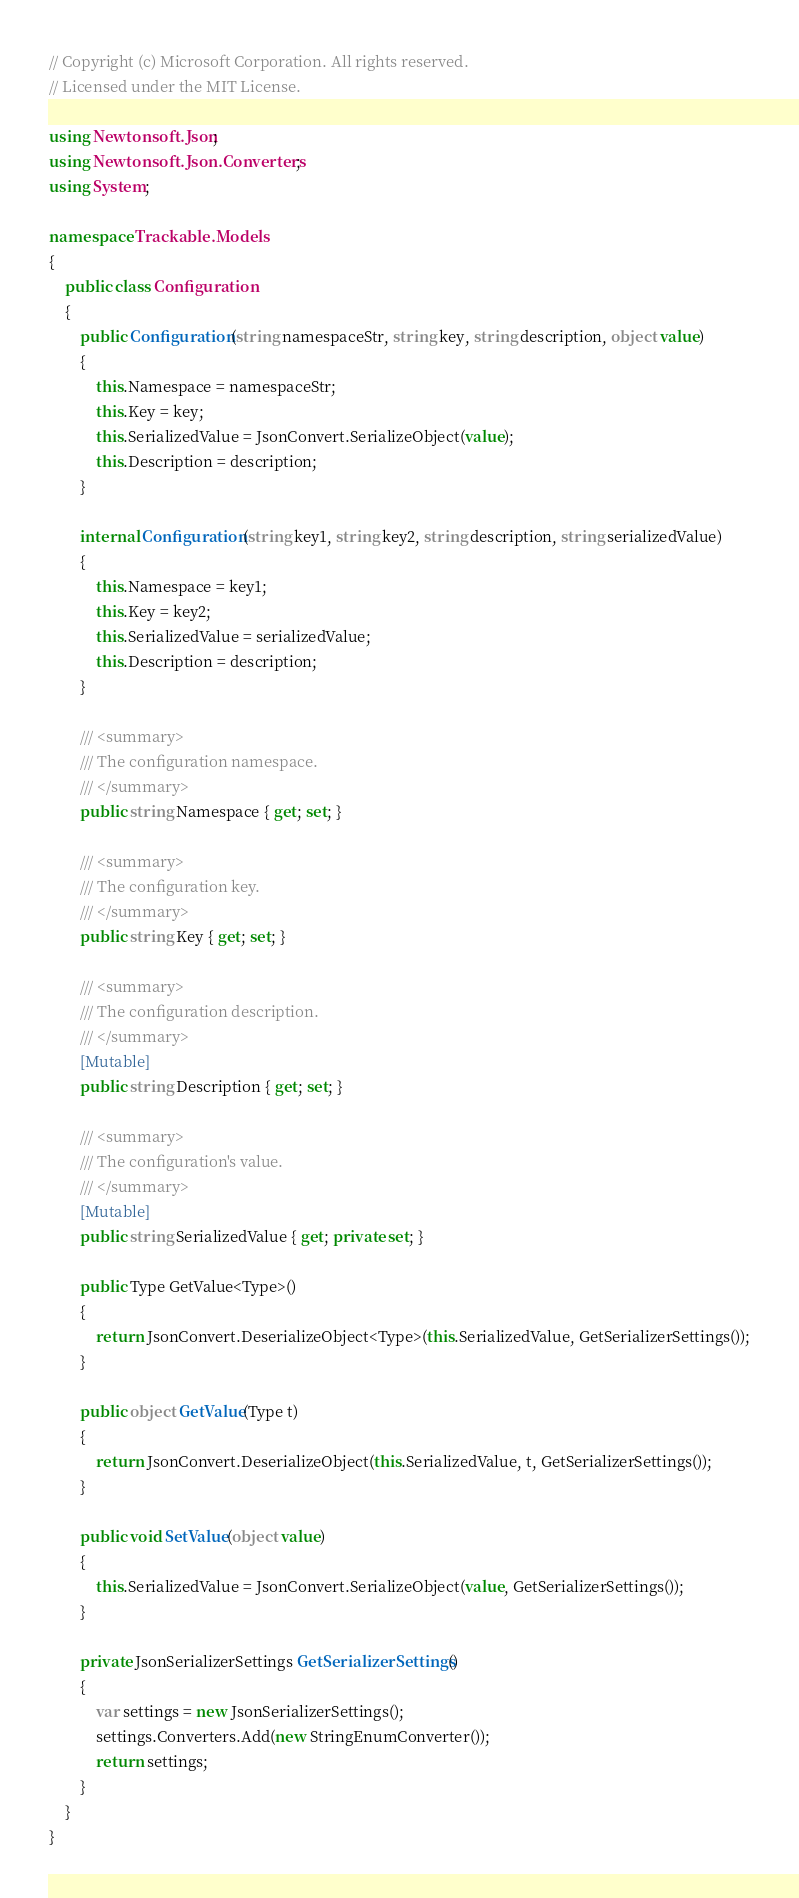<code> <loc_0><loc_0><loc_500><loc_500><_C#_>// Copyright (c) Microsoft Corporation. All rights reserved.
// Licensed under the MIT License.

using Newtonsoft.Json;
using Newtonsoft.Json.Converters;
using System;

namespace Trackable.Models
{
    public class Configuration
    {
        public Configuration(string namespaceStr, string key, string description, object value)
        {
            this.Namespace = namespaceStr;
            this.Key = key;
            this.SerializedValue = JsonConvert.SerializeObject(value);
            this.Description = description;
        }

        internal Configuration(string key1, string key2, string description, string serializedValue)
        {
            this.Namespace = key1;
            this.Key = key2;
            this.SerializedValue = serializedValue;
            this.Description = description;
        }

        /// <summary>
        /// The configuration namespace.
        /// </summary>
        public string Namespace { get; set; }

        /// <summary>
        /// The configuration key.
        /// </summary>
        public string Key { get; set; }

        /// <summary>
        /// The configuration description.
        /// </summary>
        [Mutable]
        public string Description { get; set; }

        /// <summary>
        /// The configuration's value.
        /// </summary>
        [Mutable]
        public string SerializedValue { get; private set; }

        public Type GetValue<Type>()
        {
            return JsonConvert.DeserializeObject<Type>(this.SerializedValue, GetSerializerSettings());
        }

        public object GetValue(Type t)
        {
            return JsonConvert.DeserializeObject(this.SerializedValue, t, GetSerializerSettings());
        }

        public void SetValue(object value)
        {
            this.SerializedValue = JsonConvert.SerializeObject(value, GetSerializerSettings());
        }

        private JsonSerializerSettings GetSerializerSettings()
        {
            var settings = new JsonSerializerSettings();
            settings.Converters.Add(new StringEnumConverter());
            return settings;
        }
    }
}
</code> 